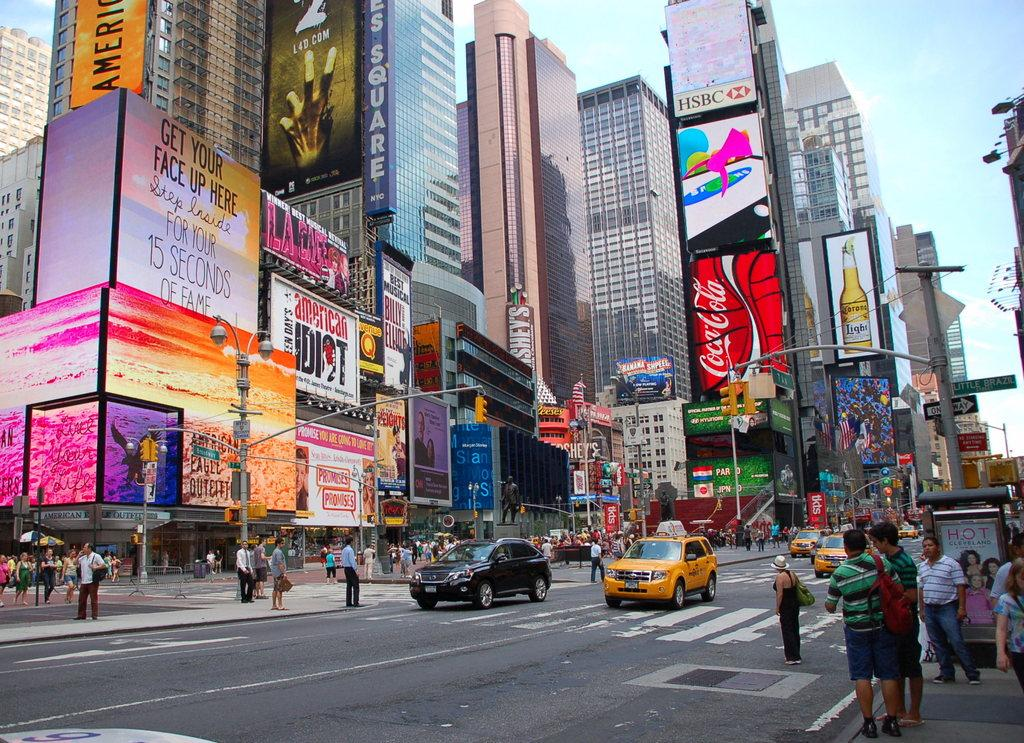Provide a one-sentence caption for the provided image. People and cars on a city street standing under electronic billboards with ads for everything from CocaCola to putting your own face up on the sign. 